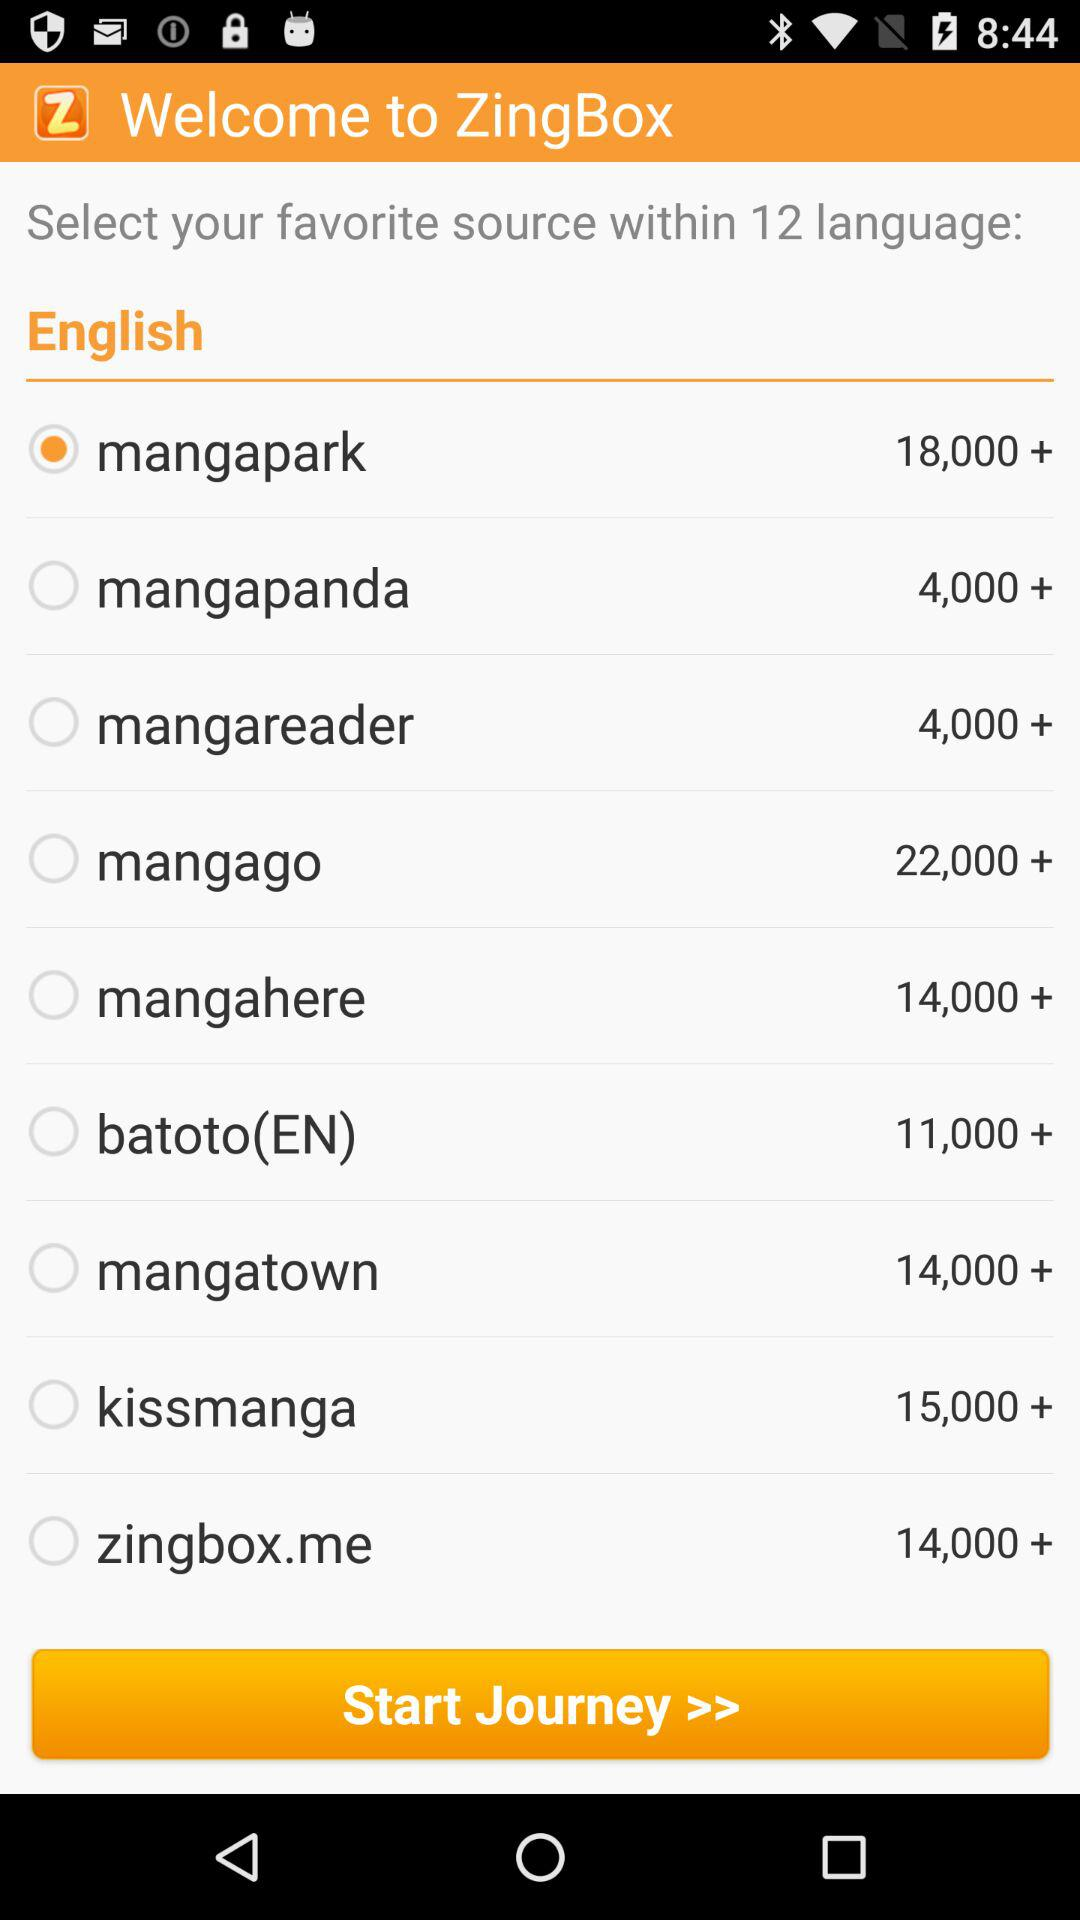How many manga sources have more than 10,000 manga?
Answer the question using a single word or phrase. 7 